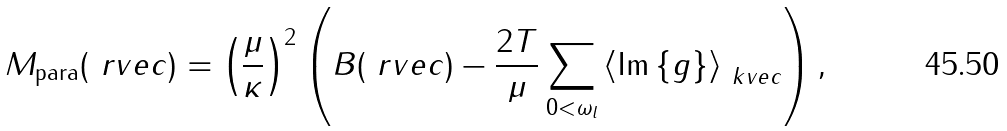<formula> <loc_0><loc_0><loc_500><loc_500>M _ { \text {para} } ( \ r v e c ) = \left ( \frac { \mu } { \kappa } \right ) ^ { 2 } \left ( B ( \ r v e c ) - \frac { 2 T } { \mu } \sum _ { 0 < \omega _ { l } } \left \langle \text {Im} \left \{ g \right \} \right \rangle _ { \ k v e c } \right ) ,</formula> 